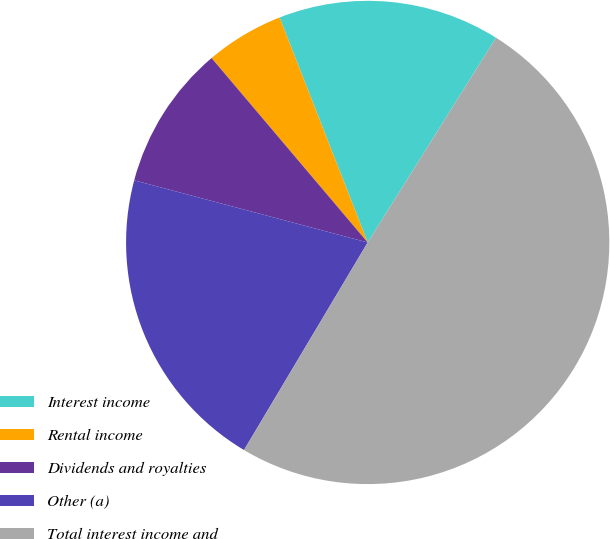Convert chart. <chart><loc_0><loc_0><loc_500><loc_500><pie_chart><fcel>Interest income<fcel>Rental income<fcel>Dividends and royalties<fcel>Other (a)<fcel>Total interest income and<nl><fcel>14.85%<fcel>5.24%<fcel>9.68%<fcel>20.59%<fcel>49.65%<nl></chart> 